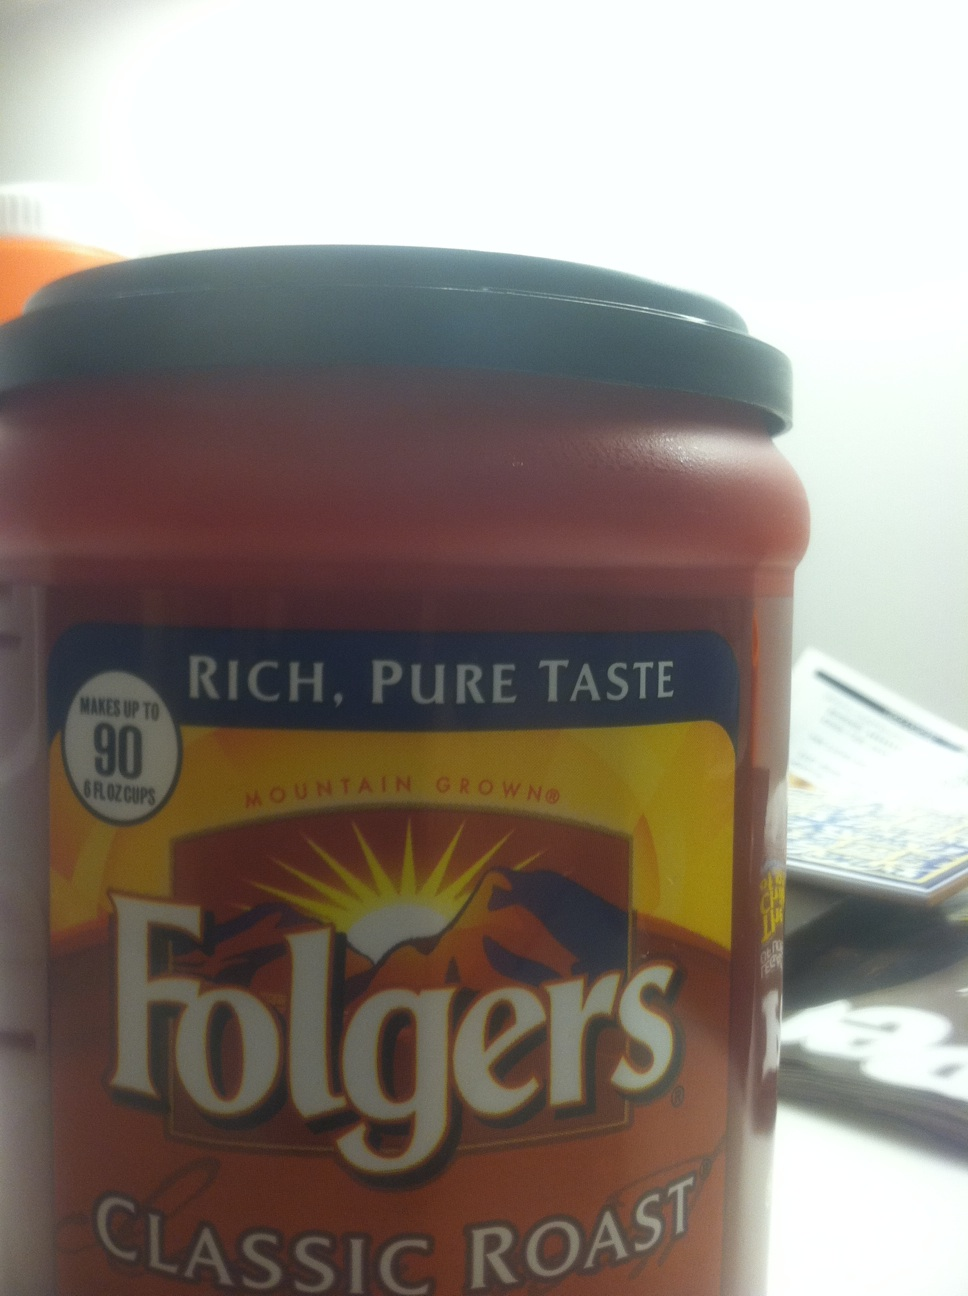How do you prepare a cup of Folgers Classic Roast for the best taste? For the best taste, start with fresh, cold water and use about one tablespoon of Folgers Classic Roast ground coffee for every 6 ounces of water. Adjust to suit your taste preferences. If using a drip coffee maker, ensure your equipment is clean for the purest flavor. Once brewed, enjoy your coffee promptly for maximum freshness and aroma. 